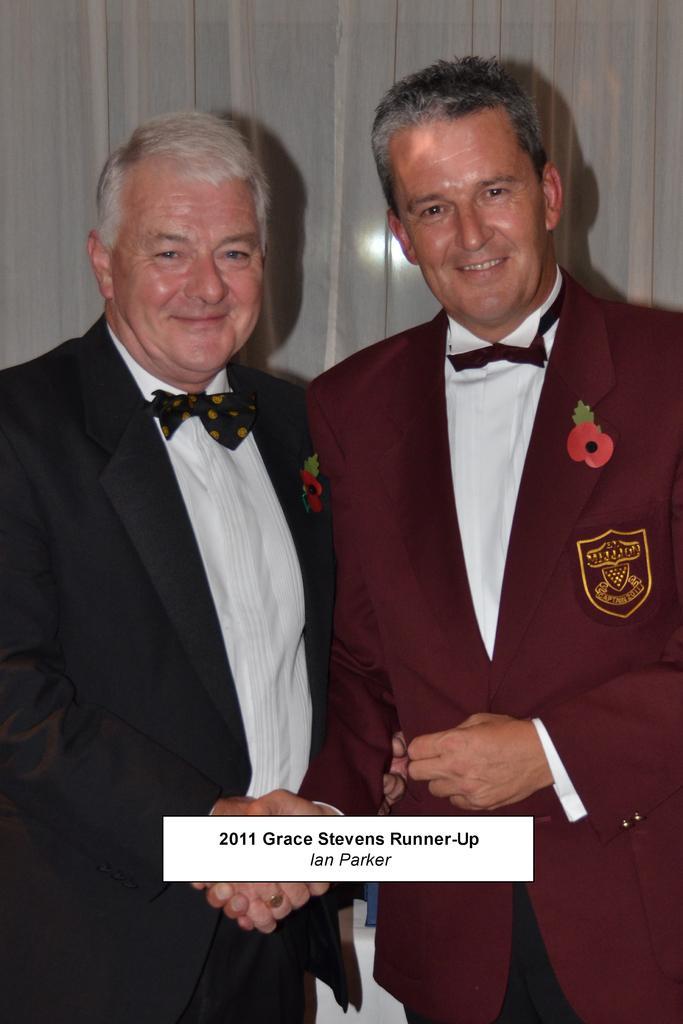Please provide a concise description of this image. In this image there are two men in the middle who are shaking their hands with each other. In the background there is a curtain. At the bottom there is some script. 